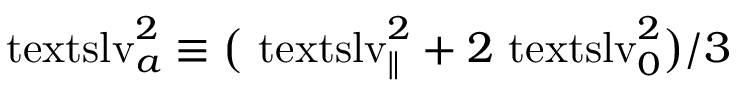Convert formula to latex. <formula><loc_0><loc_0><loc_500><loc_500>\ t e x t s l { v } _ { a } ^ { 2 } \equiv \left ( { \ t e x t s l { v } _ { \| } } ^ { 2 } + 2 { \ t e x t s l { v } _ { 0 } } ^ { 2 } \right ) / 3</formula> 